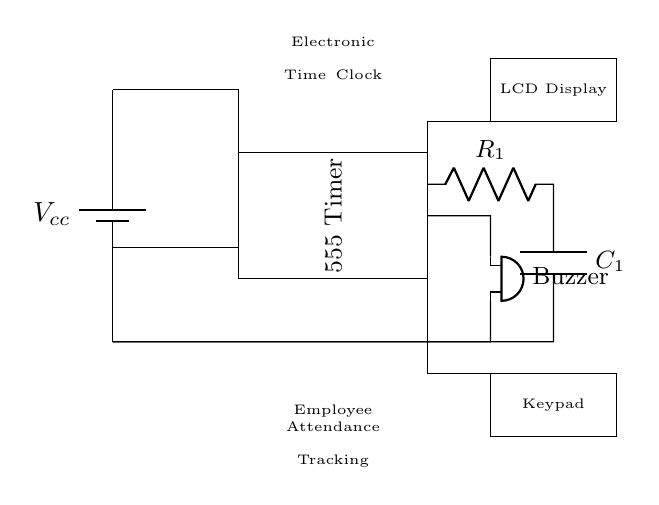What component is used as the timing element in this circuit? The timing element is created by the resistor and capacitor connected to the 555 timer. Specifically, the resistor labeled R1 and the capacitor labeled C1 work together to determine the timing interval.
Answer: Resistor and Capacitor What is the output of the 555 timer in this circuit? The output of the 555 timer is connected to a buzzer, which indicates that the timer has completed its cycle. This output can trigger an external alarm or notification.
Answer: Buzzer Which component displays the timed information? The timed information is displayed on an LCD that is connected to the 555 timer. This allows users to see the status or timing results.
Answer: LCD Display What is the purpose of the keypad in this circuit? The keypad is used for inputting data such as the specific time settings for the timer. It allows the user to interact with the electronic time clock to customize its operation.
Answer: Keypad What type of circuit is this primarily classified as? This circuit is classified as a timer circuit, specifically designed for timing functions within the context of employee attendance. It utilizes a 555 timer to achieve its timing functionality.
Answer: Timer Circuit How does the power supply connect to the circuit? The power supply, labeled Vcc, connects to the 555 timer and provides the necessary voltage for the entire circuit to operate, ensuring that all components receive adequate power for proper functioning.
Answer: Connected vertically to the timer What determines the timing interval in this circuit? The timing interval is determined by the values of the resistor R1 and the capacitor C1. These components set the charge and discharge times, which dictate how long the timer runs before signaling through the buzzer.
Answer: Resistor and Capacitor values 